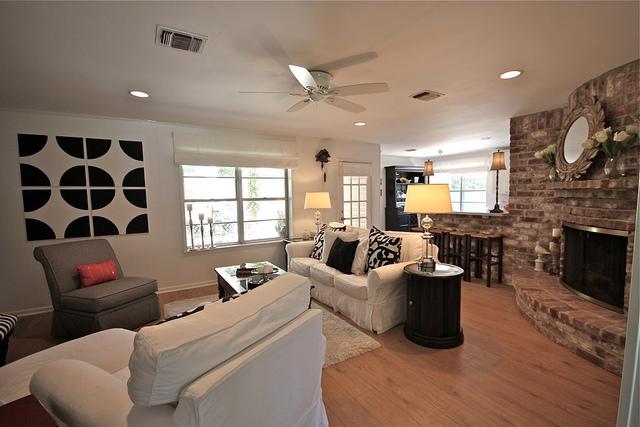How many pillows are on the couches?
Answer briefly. 5. What type of material is the rug in the upper middle made of?
Short answer required. Wool. What is on the wall above the chair?
Short answer required. Picture. Where is the mirror?
Answer briefly. Above fireplace. Is the ceiling fan on?
Concise answer only. No. Are the windows open?
Write a very short answer. No. What room are they in?
Be succinct. Living room. What color are the couches?
Write a very short answer. White. Is the room cluttered?
Quick response, please. No. Is the floor carpeted?
Keep it brief. No. 